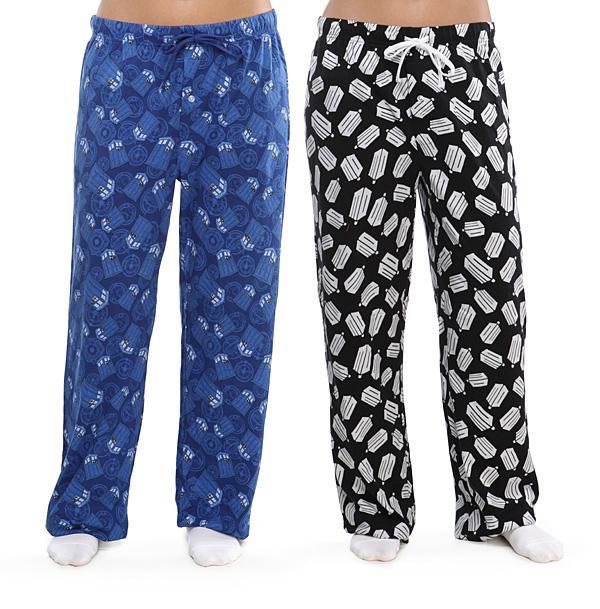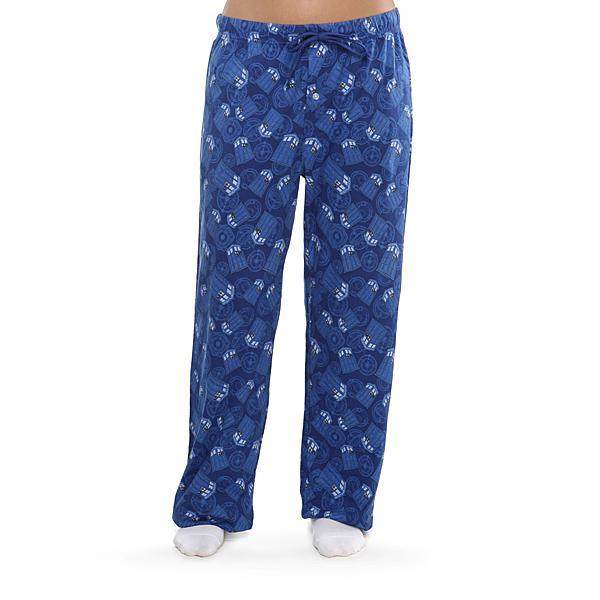The first image is the image on the left, the second image is the image on the right. For the images shown, is this caption "at least one pair of pants is worn by a human." true? Answer yes or no. Yes. 